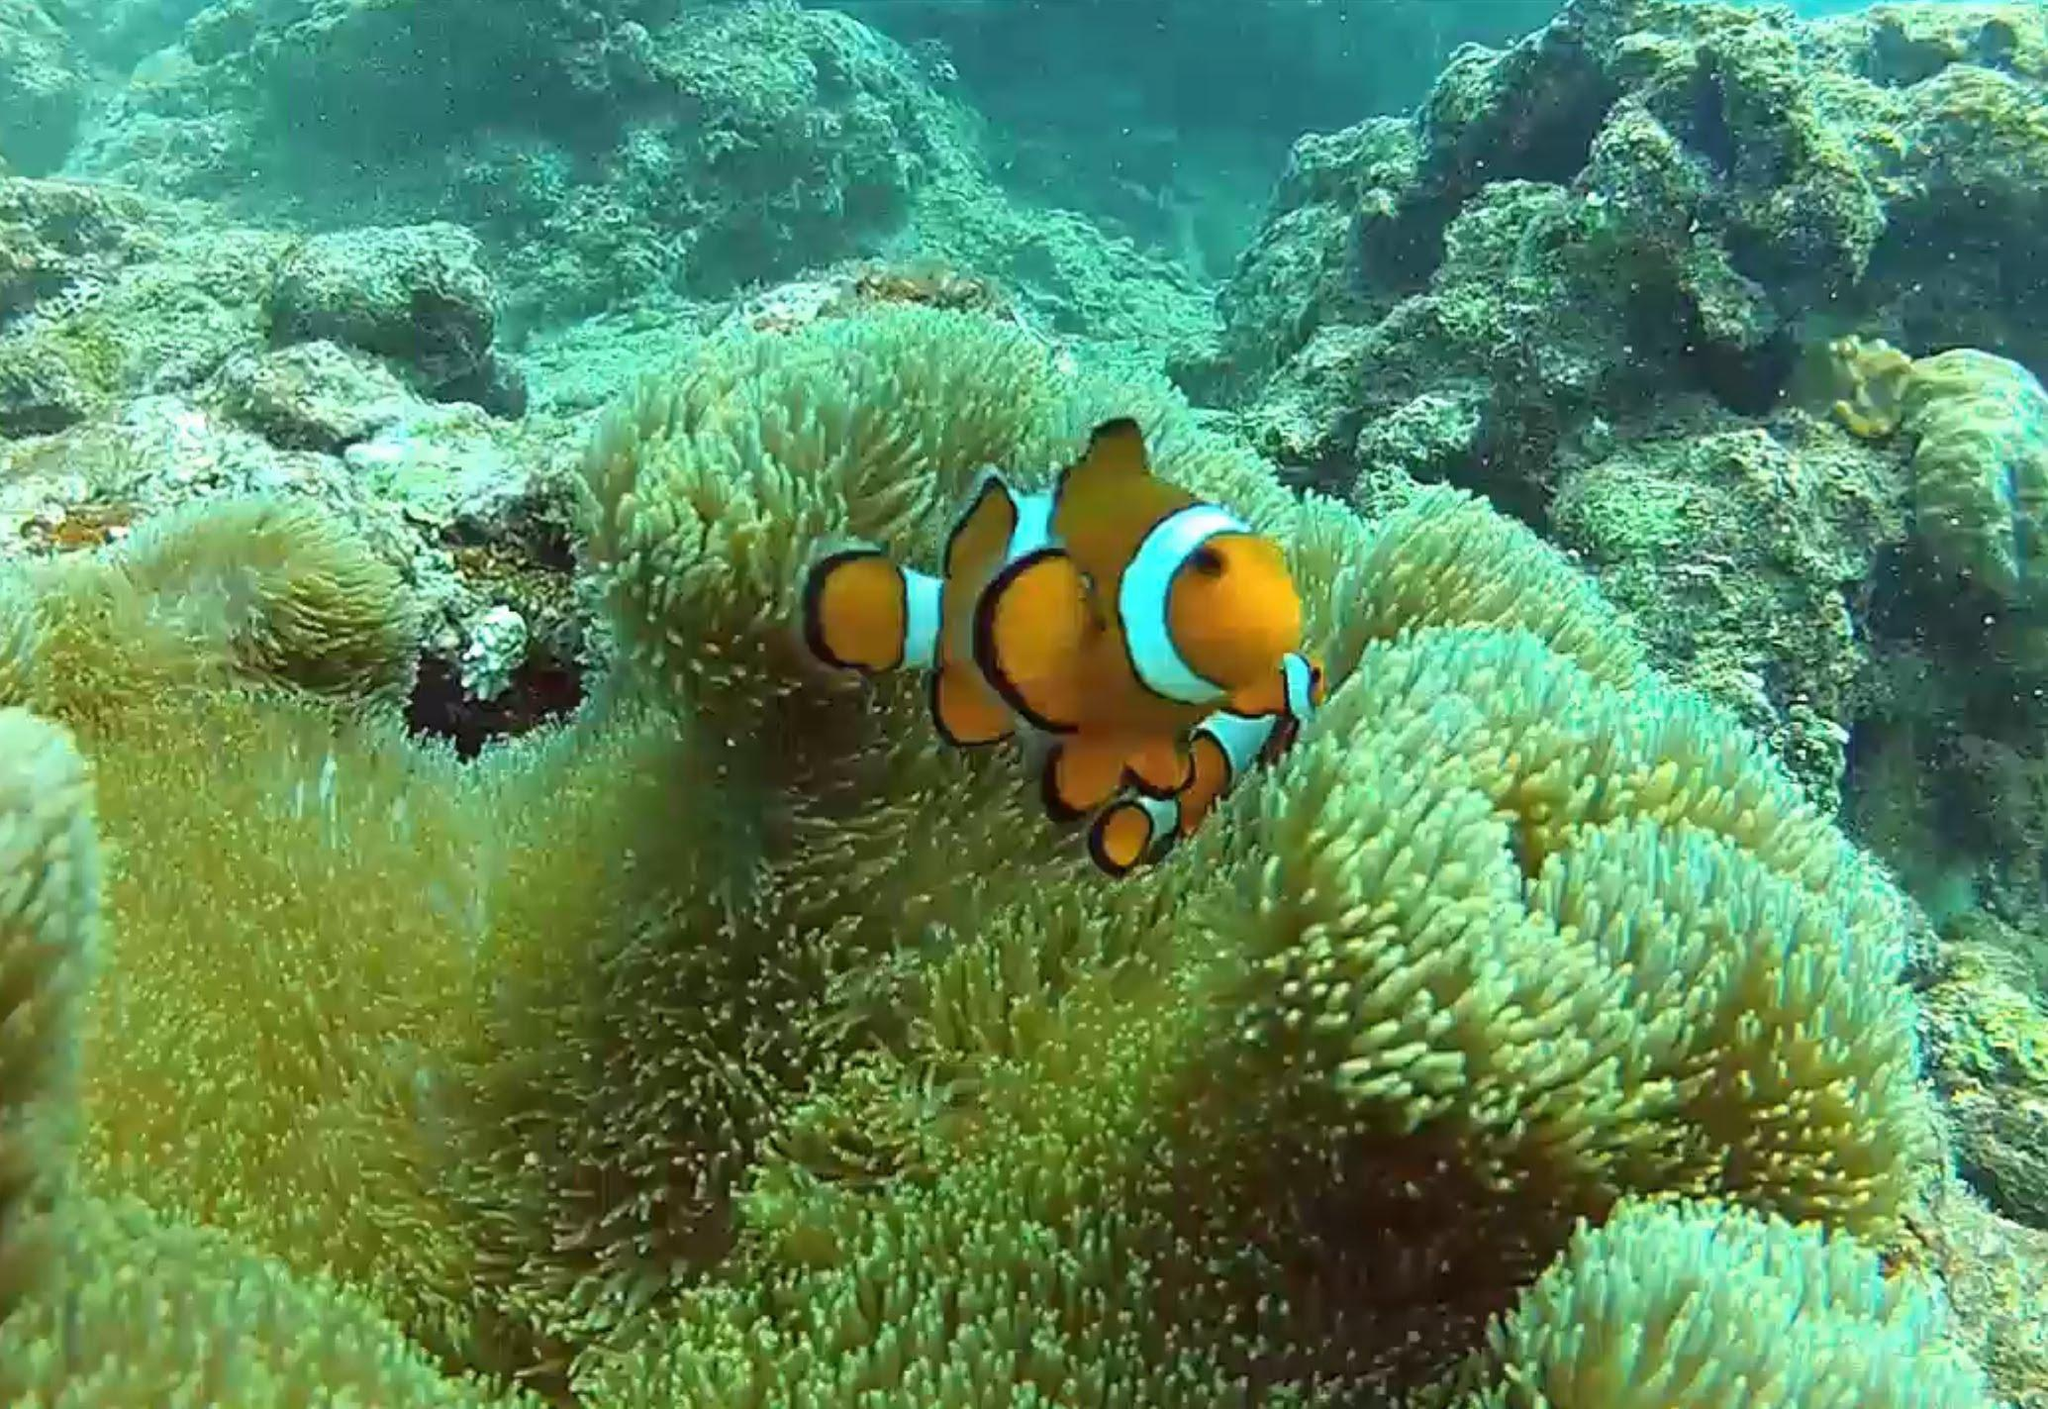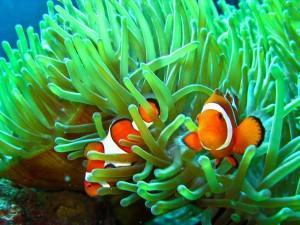The first image is the image on the left, the second image is the image on the right. Examine the images to the left and right. Is the description "There are at most three clownfish swimming." accurate? Answer yes or no. Yes. The first image is the image on the left, the second image is the image on the right. Evaluate the accuracy of this statement regarding the images: "At least three orange and white fish swim in the water.". Is it true? Answer yes or no. Yes. 